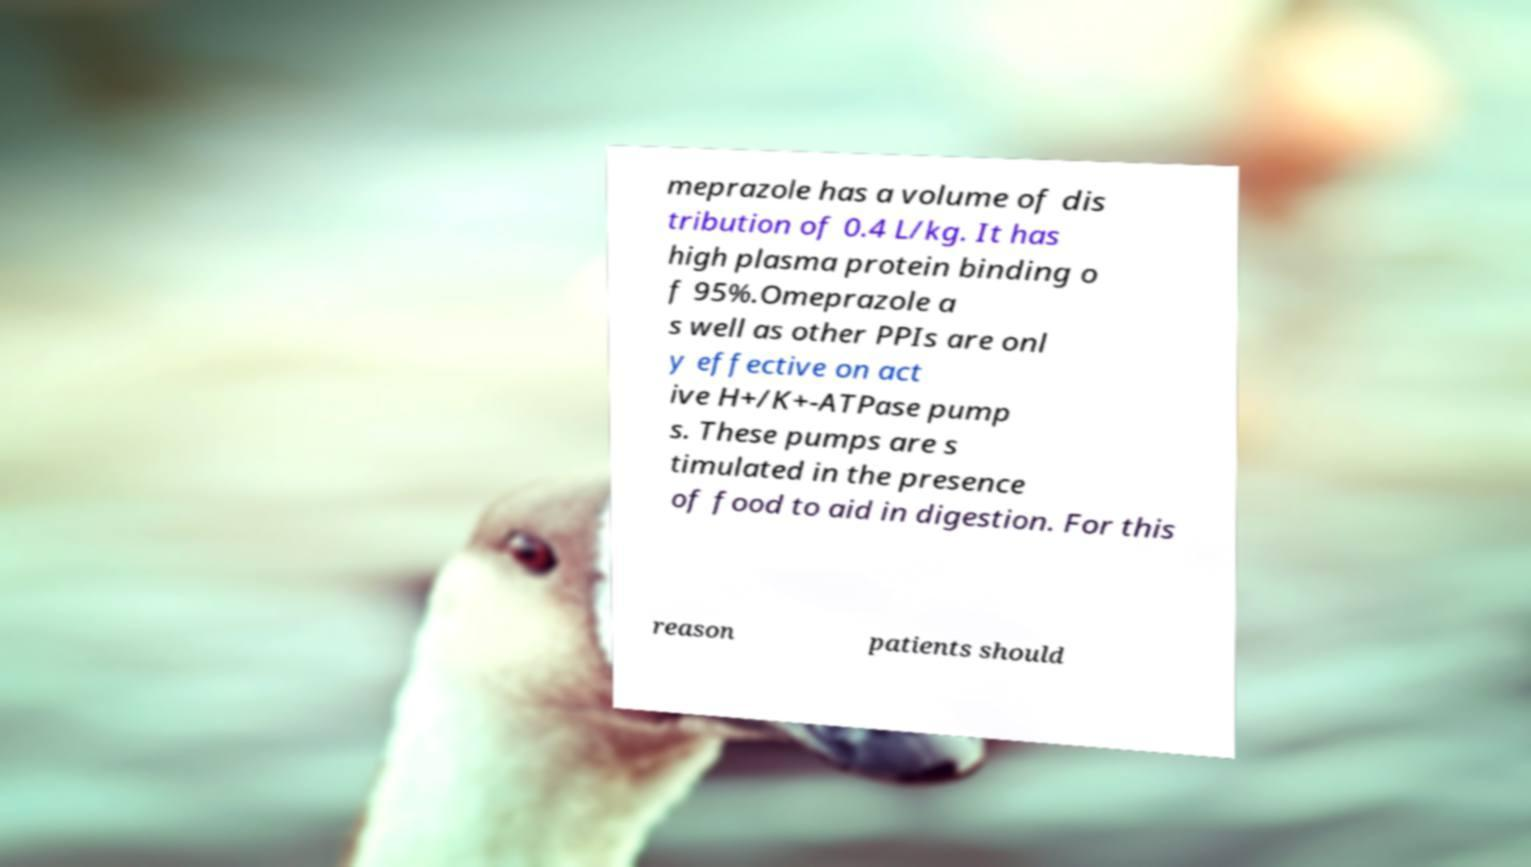Could you extract and type out the text from this image? meprazole has a volume of dis tribution of 0.4 L/kg. It has high plasma protein binding o f 95%.Omeprazole a s well as other PPIs are onl y effective on act ive H+/K+-ATPase pump s. These pumps are s timulated in the presence of food to aid in digestion. For this reason patients should 